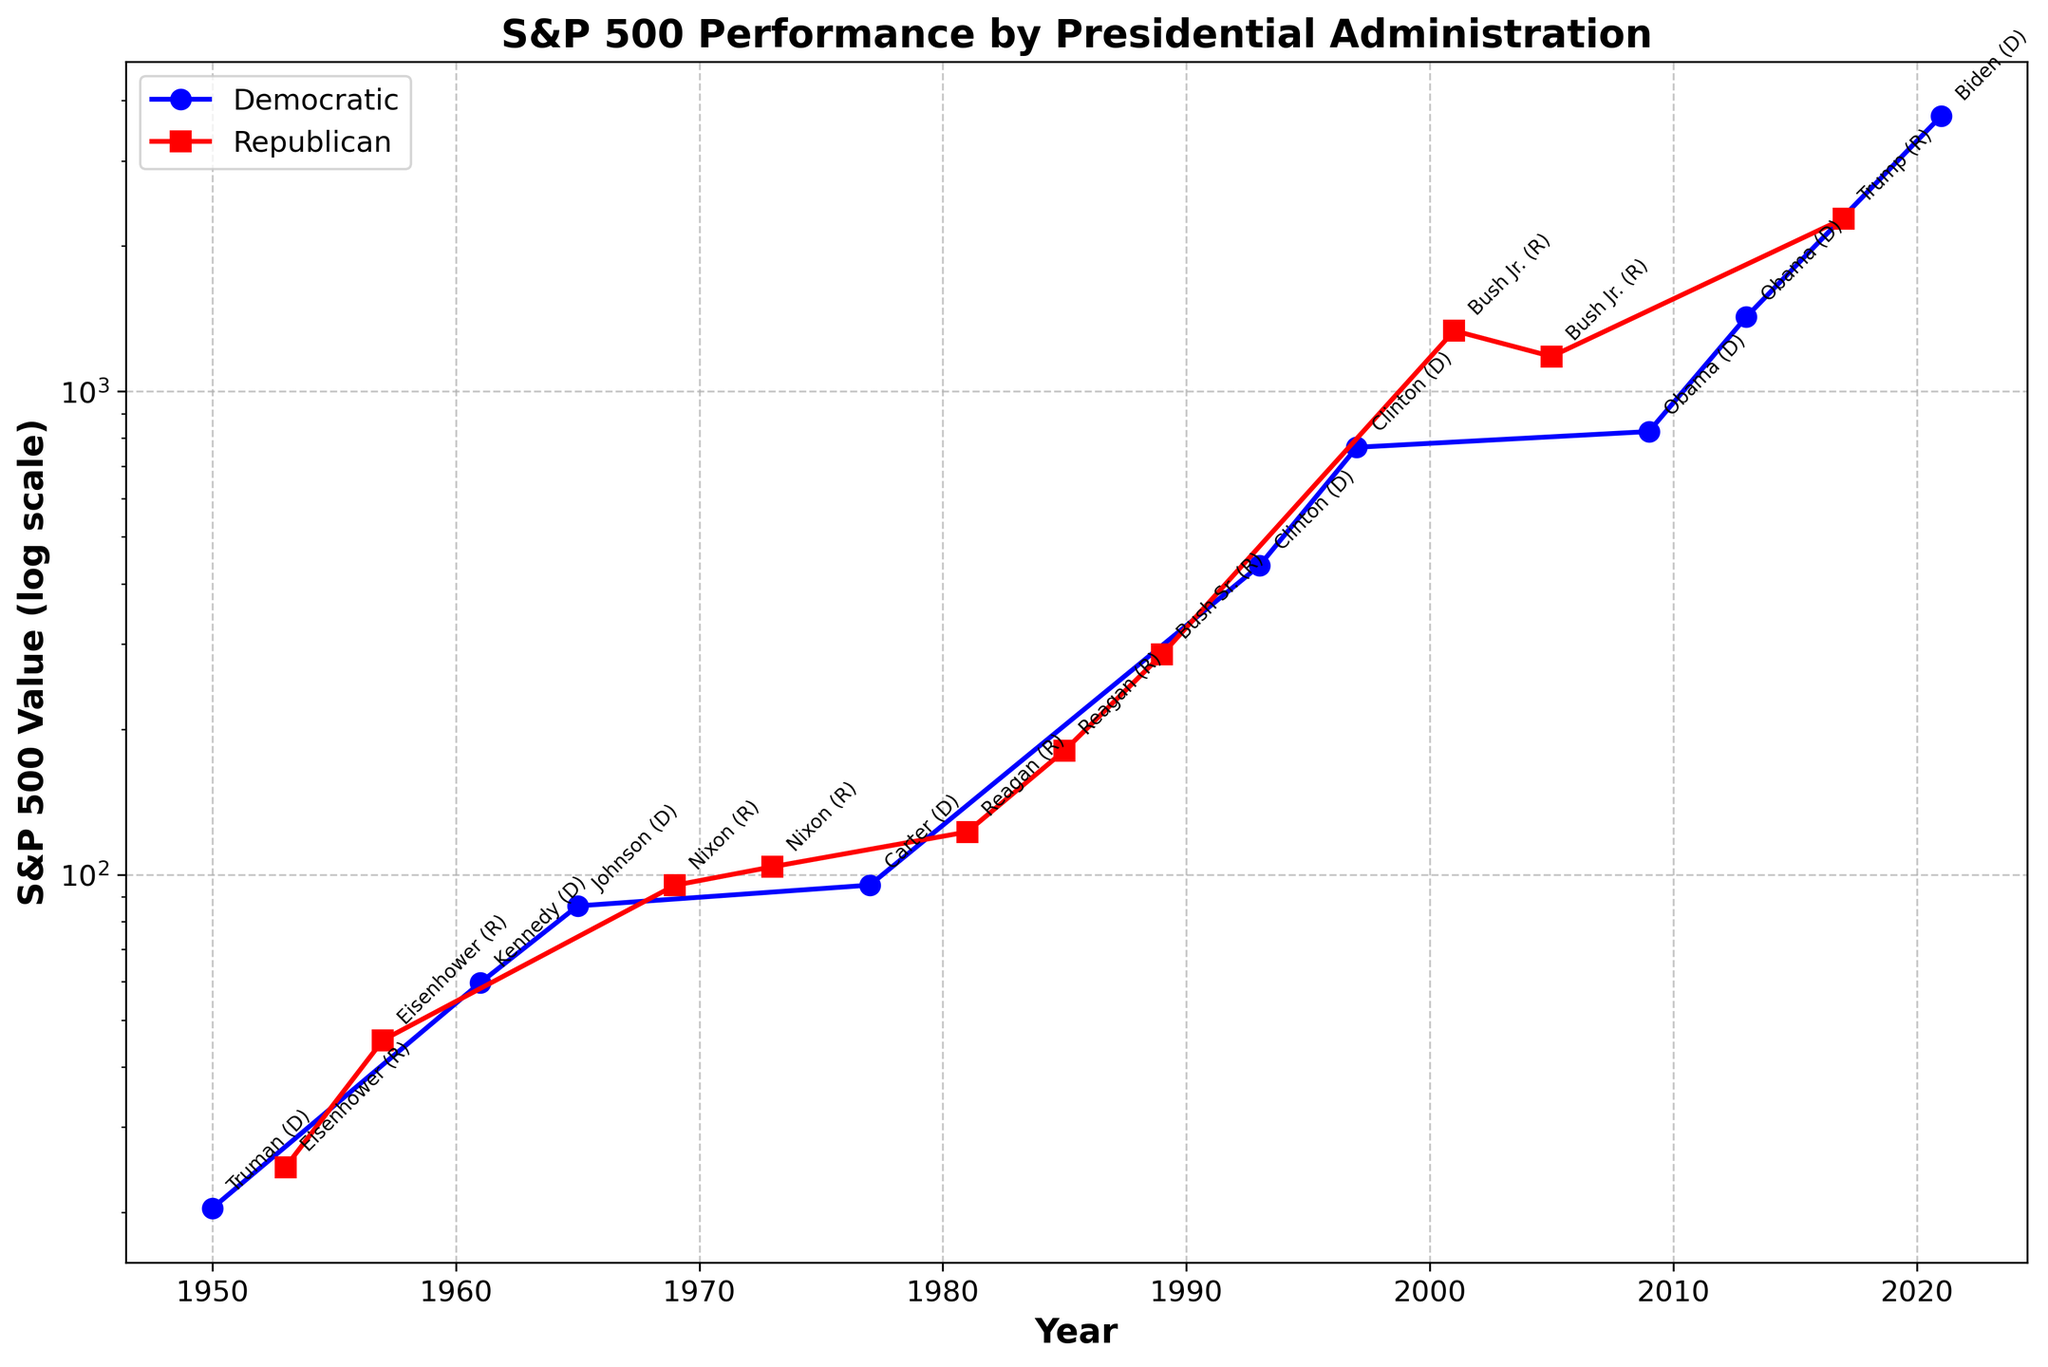What is the S&P 500 value at the beginning of Obama's administration? Obama's administration started in 2009. According to the figure, the S&P 500 value in 2009 is around 825.88
Answer: 825.88 How did the S&P 500 value change during Reagan's administration? Reagan's administration started in 1981 and ended in 1989. The S&P 500 value in 1981 was 122.55, and it increased to 285.41 by 1989. The change can be calculated as 285.41 - 122.55
Answer: Increased by 162.86 Which administration had the largest increase in S&P 500 value during its term? To determine this, we need to compare the S&P 500 values at the start and end of each administration's term. Clinton's term had the most significant increase, from 435.71 in 1993 to 766.22 in 1997, resulting in an increase of 330.51
Answer: Clinton (D) During which administration did the S&P 500 decline? By looking at the data, the S&P 500 declined during the Nixon (R) administration from 103.80 in 1973 to 95.10 in 1977
Answer: Nixon (R) What was the overall trend of the S&P 500 index during Democratic administrations? The overall trend of the S&P 500 index during Democratic administrations shows an increase. For example, it increased during Truman (D), Kennedy (D), Johnson (D), Carter (D), Clinton (D), Obama (D), and Biden (D)
Answer: Increasing trend Which administration had the highest S&P 500 value at the end of its term? The highest S&P 500 value at the end of an administration's term was during Trump (R) in 2021, with a value of 3714.24
Answer: Trump (R) How many Democratic administrations have there been since 1950? By counting the Democratic administrations listed in the data, we find there were seven: Truman, Kennedy, Johnson, Carter, Clinton, Obama, and Biden
Answer: Seven What was the S&P 500 value in 1965 and how does it compare with the value in 1969? The S&P 500 value in 1965 (Johnson (D)) was 86.12, and in 1969 (Nixon (R)), it was 95.04. The increase can be calculated as 95.04 - 86.12
Answer: Increased by 8.92 What is the overall change in the S&P 500 value from the beginning of Truman’s administration to the end of Biden’s administration? The S&P 500 value at the beginning of Truman’s administration in 1950 was 20.41, and at the end of Biden’s administration in 2021, it was 3714.24. The overall change can be calculated as 3714.24 - 20.41
Answer: Increased by 3693.83 